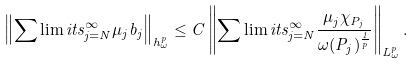Convert formula to latex. <formula><loc_0><loc_0><loc_500><loc_500>\left \| \sum \lim i t s _ { j = N } ^ { \infty } \mu _ { j } b _ { j } \right \| _ { h _ { \omega } ^ { p } } \leq C \left \| \sum \lim i t s _ { j = N } ^ { \infty } \frac { \mu _ { j } \chi _ { P _ { j } } } { \omega ( P _ { j } ) ^ { \frac { 1 } { p } } } \right \| _ { L _ { \omega } ^ { p } } .</formula> 